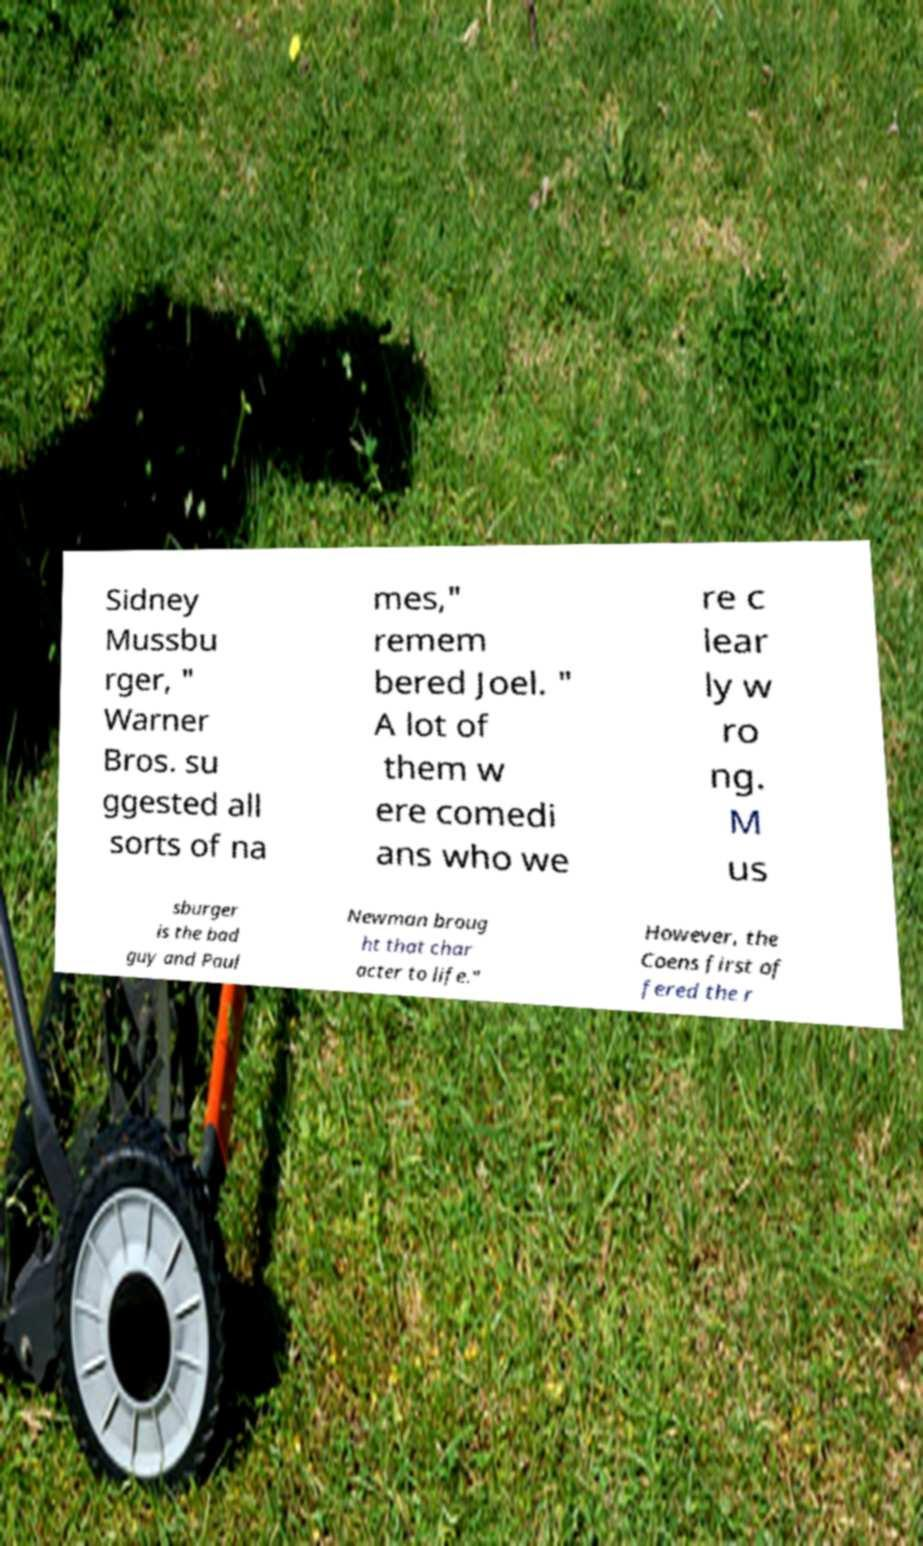There's text embedded in this image that I need extracted. Can you transcribe it verbatim? Sidney Mussbu rger, " Warner Bros. su ggested all sorts of na mes," remem bered Joel. " A lot of them w ere comedi ans who we re c lear ly w ro ng. M us sburger is the bad guy and Paul Newman broug ht that char acter to life." However, the Coens first of fered the r 